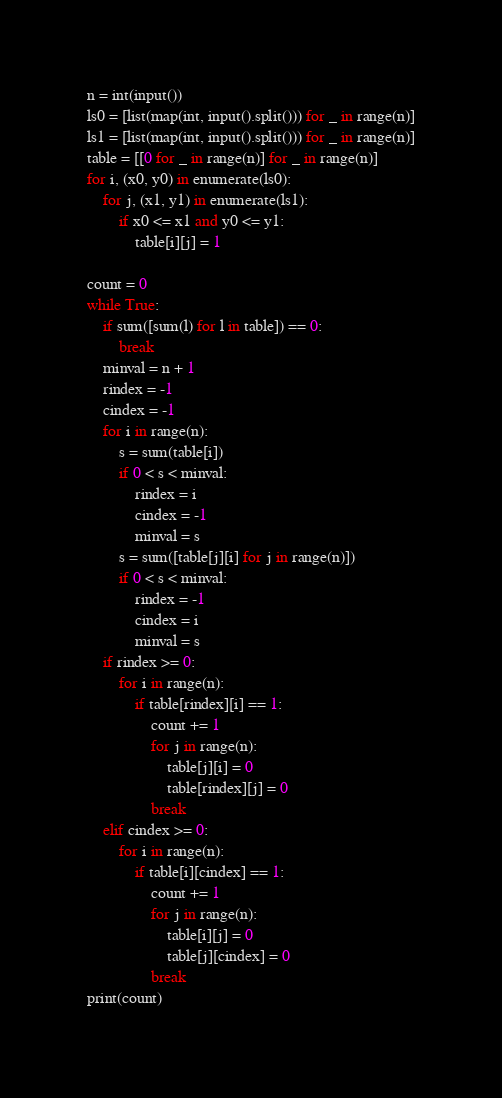<code> <loc_0><loc_0><loc_500><loc_500><_Python_>n = int(input())
ls0 = [list(map(int, input().split())) for _ in range(n)]
ls1 = [list(map(int, input().split())) for _ in range(n)]
table = [[0 for _ in range(n)] for _ in range(n)]
for i, (x0, y0) in enumerate(ls0):
    for j, (x1, y1) in enumerate(ls1):
        if x0 <= x1 and y0 <= y1:
            table[i][j] = 1

count = 0
while True:
    if sum([sum(l) for l in table]) == 0:
        break
    minval = n + 1
    rindex = -1
    cindex = -1
    for i in range(n):
        s = sum(table[i])
        if 0 < s < minval:
            rindex = i
            cindex = -1
            minval = s
        s = sum([table[j][i] for j in range(n)])
        if 0 < s < minval:
            rindex = -1
            cindex = i
            minval = s
    if rindex >= 0:
        for i in range(n):
            if table[rindex][i] == 1:
                count += 1
                for j in range(n):
                    table[j][i] = 0
                    table[rindex][j] = 0
                break
    elif cindex >= 0:
        for i in range(n):
            if table[i][cindex] == 1:
                count += 1
                for j in range(n):
                    table[i][j] = 0
                    table[j][cindex] = 0
                break
print(count)</code> 